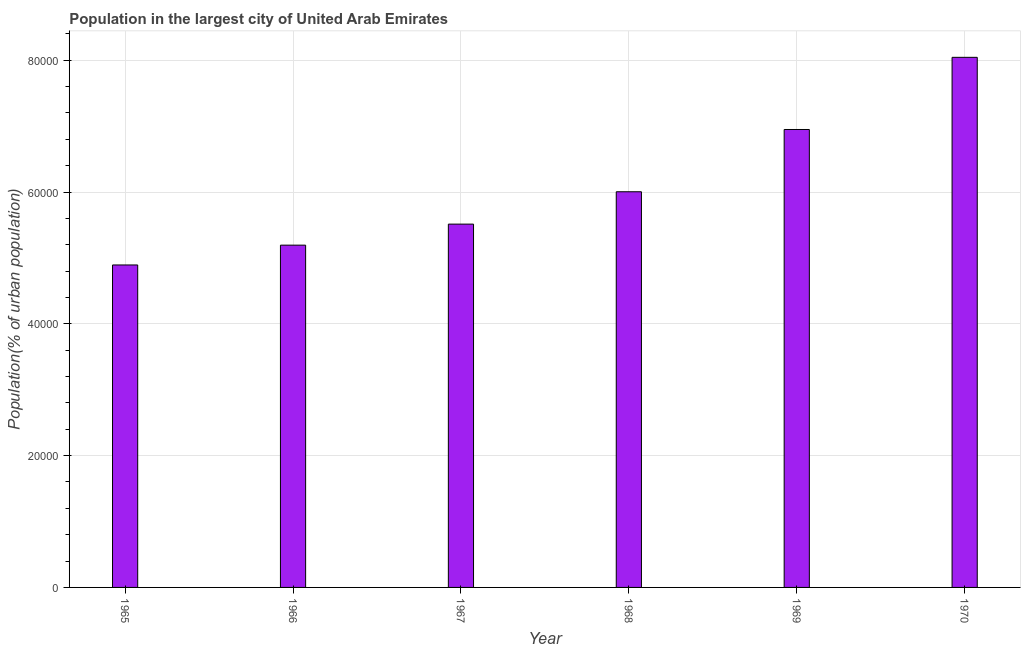What is the title of the graph?
Give a very brief answer. Population in the largest city of United Arab Emirates. What is the label or title of the Y-axis?
Give a very brief answer. Population(% of urban population). What is the population in largest city in 1968?
Your answer should be very brief. 6.00e+04. Across all years, what is the maximum population in largest city?
Offer a terse response. 8.04e+04. Across all years, what is the minimum population in largest city?
Offer a very short reply. 4.89e+04. In which year was the population in largest city minimum?
Your answer should be very brief. 1965. What is the sum of the population in largest city?
Make the answer very short. 3.66e+05. What is the difference between the population in largest city in 1967 and 1970?
Ensure brevity in your answer.  -2.53e+04. What is the average population in largest city per year?
Your answer should be very brief. 6.10e+04. What is the median population in largest city?
Your answer should be very brief. 5.76e+04. In how many years, is the population in largest city greater than 48000 %?
Keep it short and to the point. 6. Do a majority of the years between 1967 and 1970 (inclusive) have population in largest city greater than 64000 %?
Offer a terse response. No. What is the ratio of the population in largest city in 1967 to that in 1969?
Your response must be concise. 0.79. Is the population in largest city in 1965 less than that in 1968?
Your response must be concise. Yes. What is the difference between the highest and the second highest population in largest city?
Give a very brief answer. 1.10e+04. Is the sum of the population in largest city in 1968 and 1969 greater than the maximum population in largest city across all years?
Your response must be concise. Yes. What is the difference between the highest and the lowest population in largest city?
Keep it short and to the point. 3.15e+04. How many bars are there?
Your answer should be compact. 6. Are all the bars in the graph horizontal?
Your answer should be compact. No. What is the difference between two consecutive major ticks on the Y-axis?
Your answer should be compact. 2.00e+04. Are the values on the major ticks of Y-axis written in scientific E-notation?
Offer a very short reply. No. What is the Population(% of urban population) of 1965?
Give a very brief answer. 4.89e+04. What is the Population(% of urban population) of 1966?
Give a very brief answer. 5.19e+04. What is the Population(% of urban population) in 1967?
Provide a short and direct response. 5.51e+04. What is the Population(% of urban population) of 1968?
Make the answer very short. 6.00e+04. What is the Population(% of urban population) in 1969?
Offer a terse response. 6.95e+04. What is the Population(% of urban population) of 1970?
Your response must be concise. 8.04e+04. What is the difference between the Population(% of urban population) in 1965 and 1966?
Offer a terse response. -3007. What is the difference between the Population(% of urban population) in 1965 and 1967?
Provide a succinct answer. -6199. What is the difference between the Population(% of urban population) in 1965 and 1968?
Ensure brevity in your answer.  -1.11e+04. What is the difference between the Population(% of urban population) in 1965 and 1969?
Your answer should be compact. -2.06e+04. What is the difference between the Population(% of urban population) in 1965 and 1970?
Offer a very short reply. -3.15e+04. What is the difference between the Population(% of urban population) in 1966 and 1967?
Ensure brevity in your answer.  -3192. What is the difference between the Population(% of urban population) in 1966 and 1968?
Give a very brief answer. -8101. What is the difference between the Population(% of urban population) in 1966 and 1969?
Your answer should be compact. -1.75e+04. What is the difference between the Population(% of urban population) in 1966 and 1970?
Keep it short and to the point. -2.85e+04. What is the difference between the Population(% of urban population) in 1967 and 1968?
Offer a terse response. -4909. What is the difference between the Population(% of urban population) in 1967 and 1969?
Give a very brief answer. -1.44e+04. What is the difference between the Population(% of urban population) in 1967 and 1970?
Offer a very short reply. -2.53e+04. What is the difference between the Population(% of urban population) in 1968 and 1969?
Your answer should be compact. -9448. What is the difference between the Population(% of urban population) in 1968 and 1970?
Provide a succinct answer. -2.04e+04. What is the difference between the Population(% of urban population) in 1969 and 1970?
Offer a terse response. -1.10e+04. What is the ratio of the Population(% of urban population) in 1965 to that in 1966?
Provide a succinct answer. 0.94. What is the ratio of the Population(% of urban population) in 1965 to that in 1967?
Your answer should be very brief. 0.89. What is the ratio of the Population(% of urban population) in 1965 to that in 1968?
Make the answer very short. 0.81. What is the ratio of the Population(% of urban population) in 1965 to that in 1969?
Provide a succinct answer. 0.7. What is the ratio of the Population(% of urban population) in 1965 to that in 1970?
Offer a terse response. 0.61. What is the ratio of the Population(% of urban population) in 1966 to that in 1967?
Provide a short and direct response. 0.94. What is the ratio of the Population(% of urban population) in 1966 to that in 1968?
Keep it short and to the point. 0.86. What is the ratio of the Population(% of urban population) in 1966 to that in 1969?
Give a very brief answer. 0.75. What is the ratio of the Population(% of urban population) in 1966 to that in 1970?
Keep it short and to the point. 0.65. What is the ratio of the Population(% of urban population) in 1967 to that in 1968?
Offer a terse response. 0.92. What is the ratio of the Population(% of urban population) in 1967 to that in 1969?
Provide a succinct answer. 0.79. What is the ratio of the Population(% of urban population) in 1967 to that in 1970?
Make the answer very short. 0.69. What is the ratio of the Population(% of urban population) in 1968 to that in 1969?
Give a very brief answer. 0.86. What is the ratio of the Population(% of urban population) in 1968 to that in 1970?
Keep it short and to the point. 0.75. What is the ratio of the Population(% of urban population) in 1969 to that in 1970?
Keep it short and to the point. 0.86. 